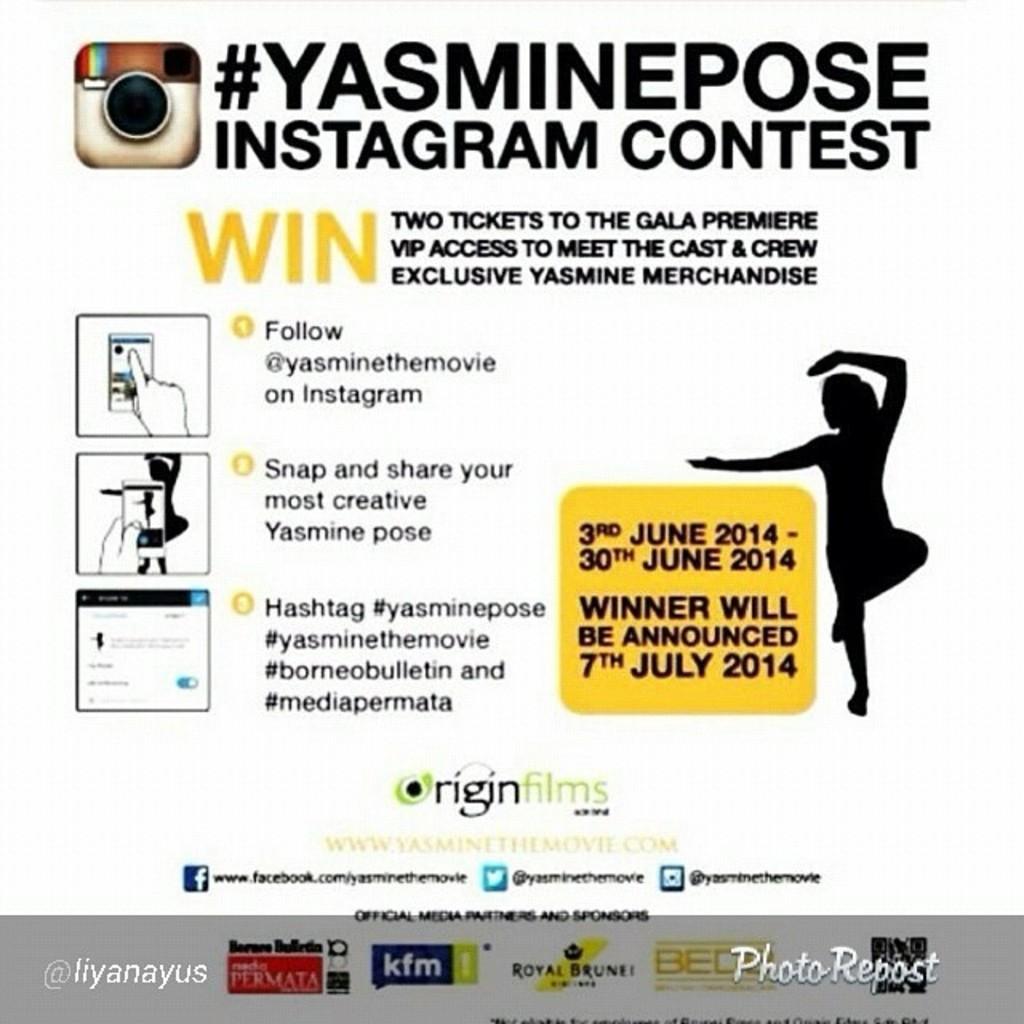How would you summarize this image in a sentence or two? In this image I can see a paper, on the paper I can see a person standing and a camera, and few things written on the paper. 